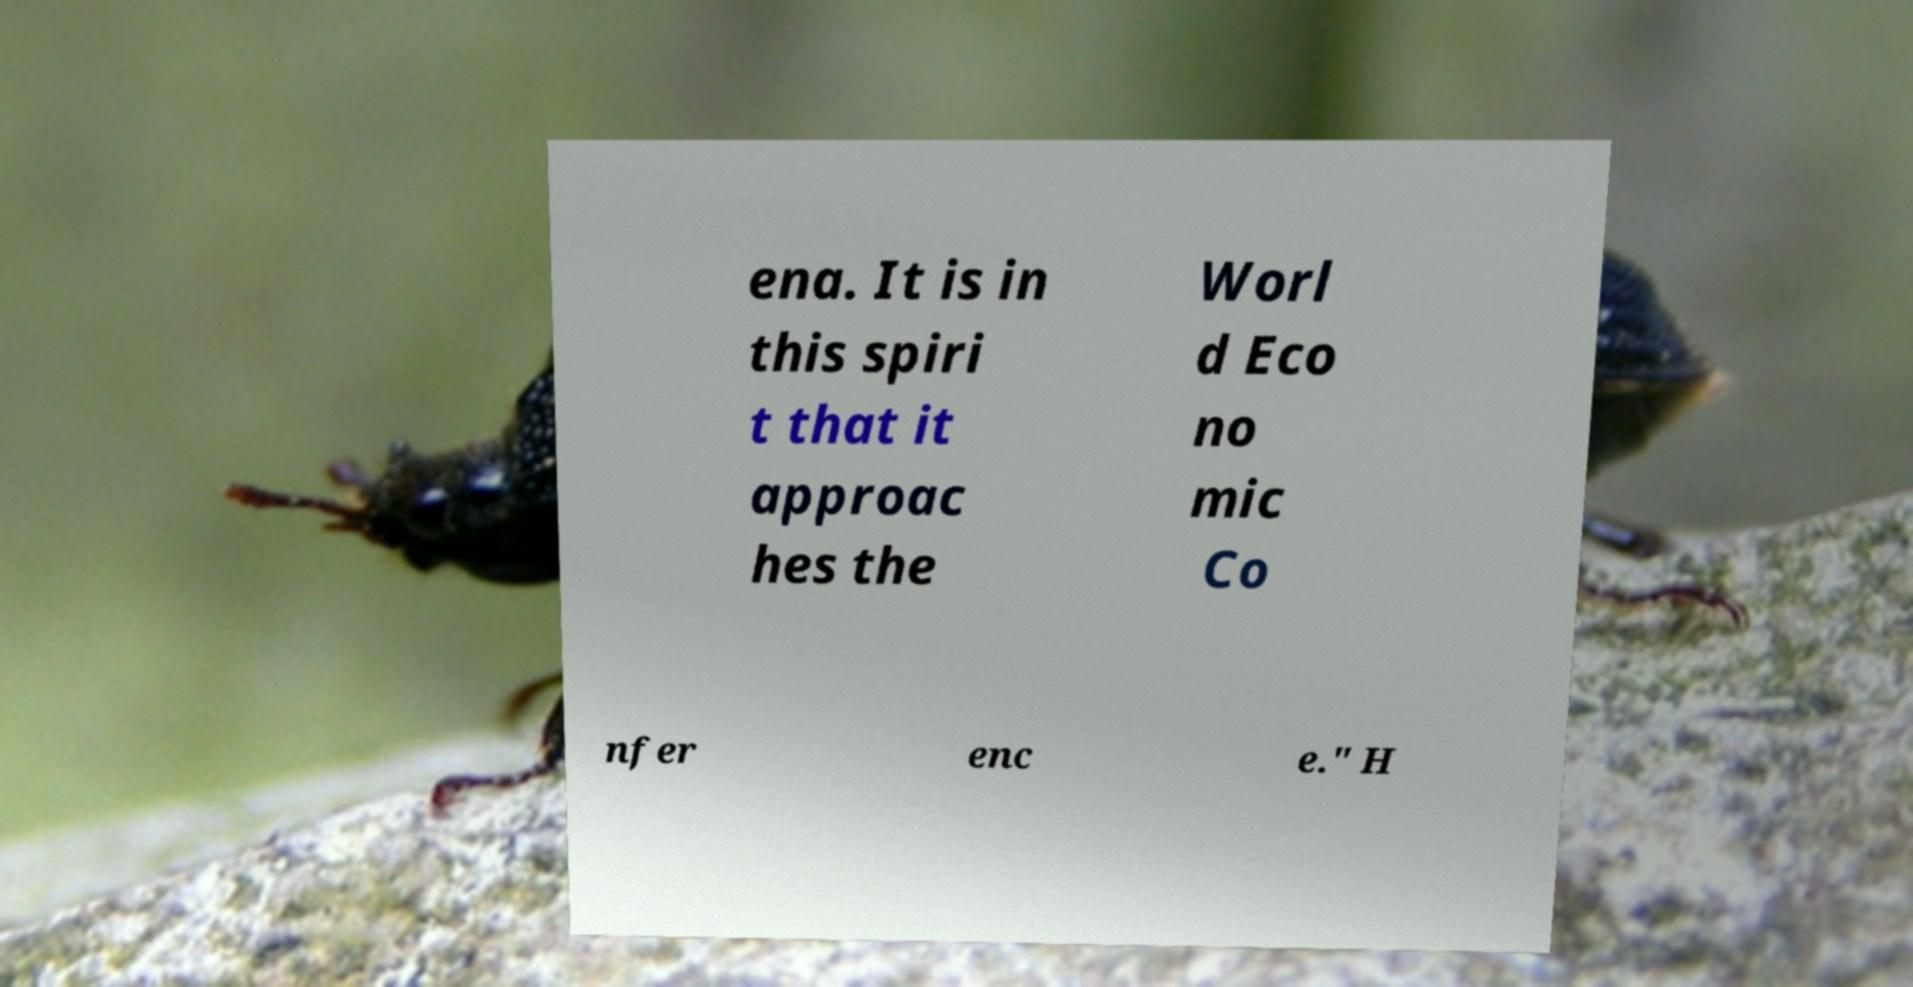For documentation purposes, I need the text within this image transcribed. Could you provide that? ena. It is in this spiri t that it approac hes the Worl d Eco no mic Co nfer enc e." H 